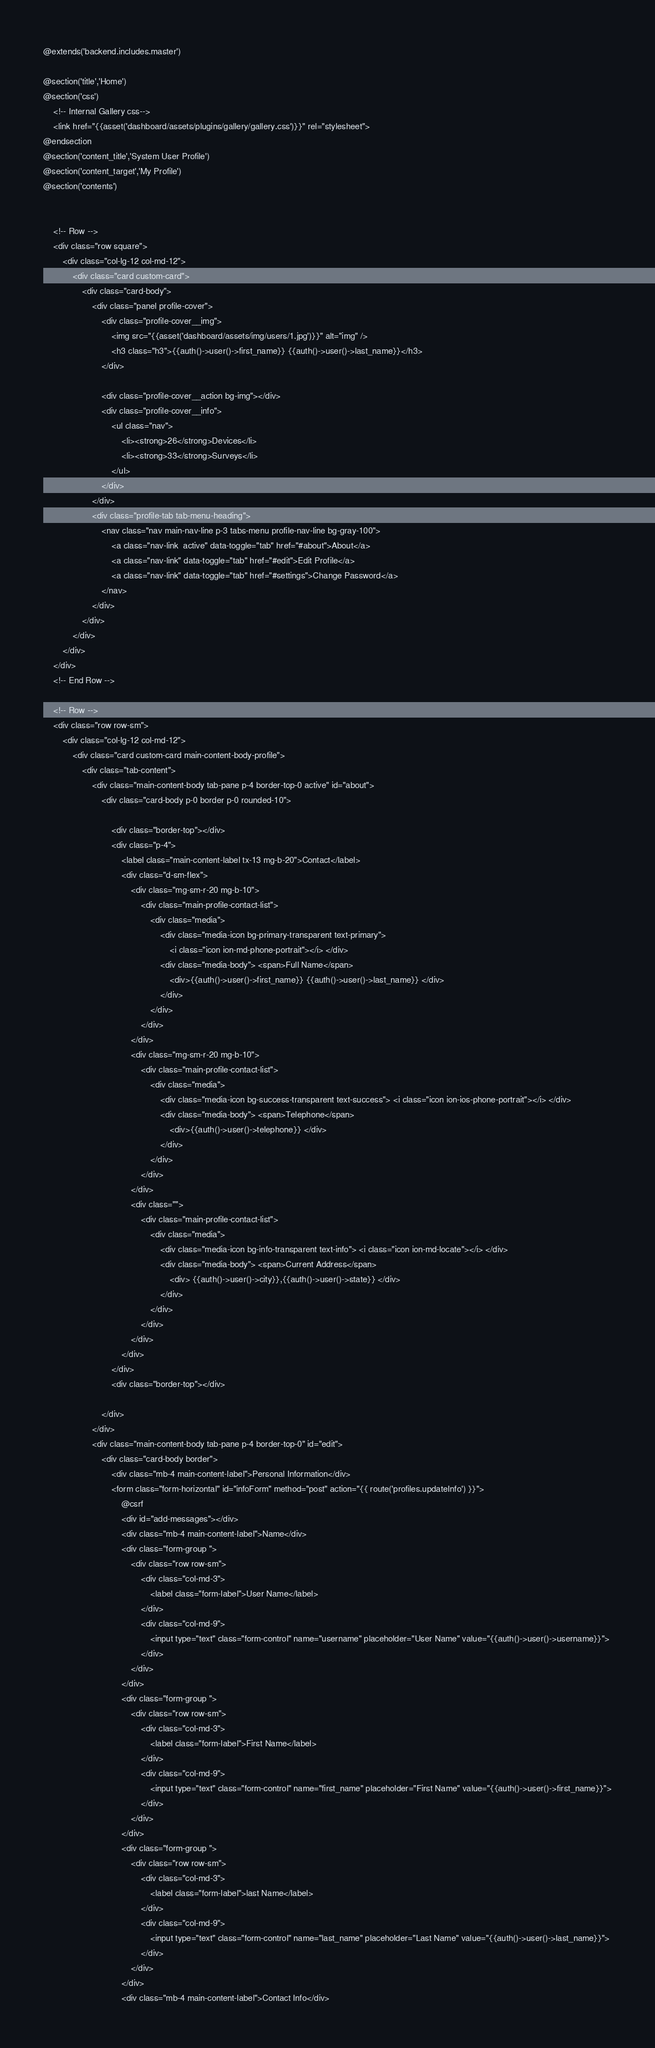<code> <loc_0><loc_0><loc_500><loc_500><_PHP_>@extends('backend.includes.master')

@section('title','Home')
@section('css')
    <!-- Internal Gallery css-->
    <link href="{{asset('dashboard/assets/plugins/gallery/gallery.css')}}" rel="stylesheet">
@endsection
@section('content_title','System User Profile')
@section('content_target','My Profile')
@section('contents')


    <!-- Row -->
    <div class="row square">
        <div class="col-lg-12 col-md-12">
            <div class="card custom-card">
                <div class="card-body">
                    <div class="panel profile-cover">
                        <div class="profile-cover__img">
                            <img src="{{asset('dashboard/assets/img/users/1.jpg')}}" alt="img" />
                            <h3 class="h3">{{auth()->user()->first_name}} {{auth()->user()->last_name}}</h3>
                        </div>

                        <div class="profile-cover__action bg-img"></div>
                        <div class="profile-cover__info">
                            <ul class="nav">
                                <li><strong>26</strong>Devices</li>
                                <li><strong>33</strong>Surveys</li>
                            </ul>
                        </div>
                    </div>
                    <div class="profile-tab tab-menu-heading">
                        <nav class="nav main-nav-line p-3 tabs-menu profile-nav-line bg-gray-100">
                            <a class="nav-link  active" data-toggle="tab" href="#about">About</a>
                            <a class="nav-link" data-toggle="tab" href="#edit">Edit Profile</a>
                            <a class="nav-link" data-toggle="tab" href="#settings">Change Password</a>
                        </nav>
                    </div>
                </div>
            </div>
        </div>
    </div>
    <!-- End Row -->

    <!-- Row -->
    <div class="row row-sm">
        <div class="col-lg-12 col-md-12">
            <div class="card custom-card main-content-body-profile">
                <div class="tab-content">
                    <div class="main-content-body tab-pane p-4 border-top-0 active" id="about">
                        <div class="card-body p-0 border p-0 rounded-10">

                            <div class="border-top"></div>
                            <div class="p-4">
                                <label class="main-content-label tx-13 mg-b-20">Contact</label>
                                <div class="d-sm-flex">
                                    <div class="mg-sm-r-20 mg-b-10">
                                        <div class="main-profile-contact-list">
                                            <div class="media">
                                                <div class="media-icon bg-primary-transparent text-primary">
                                                    <i class="icon ion-md-phone-portrait"></i> </div>
                                                <div class="media-body"> <span>Full Name</span>
                                                    <div>{{auth()->user()->first_name}} {{auth()->user()->last_name}} </div>
                                                </div>
                                            </div>
                                        </div>
                                    </div>
                                    <div class="mg-sm-r-20 mg-b-10">
                                        <div class="main-profile-contact-list">
                                            <div class="media">
                                                <div class="media-icon bg-success-transparent text-success"> <i class="icon ion-ios-phone-portrait"></i> </div>
                                                <div class="media-body"> <span>Telephone</span>
                                                    <div>{{auth()->user()->telephone}} </div>
                                                </div>
                                            </div>
                                        </div>
                                    </div>
                                    <div class="">
                                        <div class="main-profile-contact-list">
                                            <div class="media">
                                                <div class="media-icon bg-info-transparent text-info"> <i class="icon ion-md-locate"></i> </div>
                                                <div class="media-body"> <span>Current Address</span>
                                                    <div> {{auth()->user()->city}},{{auth()->user()->state}} </div>
                                                </div>
                                            </div>
                                        </div>
                                    </div>
                                </div>
                            </div>
                            <div class="border-top"></div>

                        </div>
                    </div>
                    <div class="main-content-body tab-pane p-4 border-top-0" id="edit">
                        <div class="card-body border">
                            <div class="mb-4 main-content-label">Personal Information</div>
                            <form class="form-horizontal" id="infoForm" method="post" action="{{ route('profiles.updateInfo') }}">
                                @csrf
                                <div id="add-messages"></div>
                                <div class="mb-4 main-content-label">Name</div>
                                <div class="form-group ">
                                    <div class="row row-sm">
                                        <div class="col-md-3">
                                            <label class="form-label">User Name</label>
                                        </div>
                                        <div class="col-md-9">
                                            <input type="text" class="form-control" name="username" placeholder="User Name" value="{{auth()->user()->username}}">
                                        </div>
                                    </div>
                                </div>
                                <div class="form-group ">
                                    <div class="row row-sm">
                                        <div class="col-md-3">
                                            <label class="form-label">First Name</label>
                                        </div>
                                        <div class="col-md-9">
                                            <input type="text" class="form-control" name="first_name" placeholder="First Name" value="{{auth()->user()->first_name}}">
                                        </div>
                                    </div>
                                </div>
                                <div class="form-group ">
                                    <div class="row row-sm">
                                        <div class="col-md-3">
                                            <label class="form-label">last Name</label>
                                        </div>
                                        <div class="col-md-9">
                                            <input type="text" class="form-control" name="last_name" placeholder="Last Name" value="{{auth()->user()->last_name}}">
                                        </div>
                                    </div>
                                </div>
                                <div class="mb-4 main-content-label">Contact Info</div></code> 